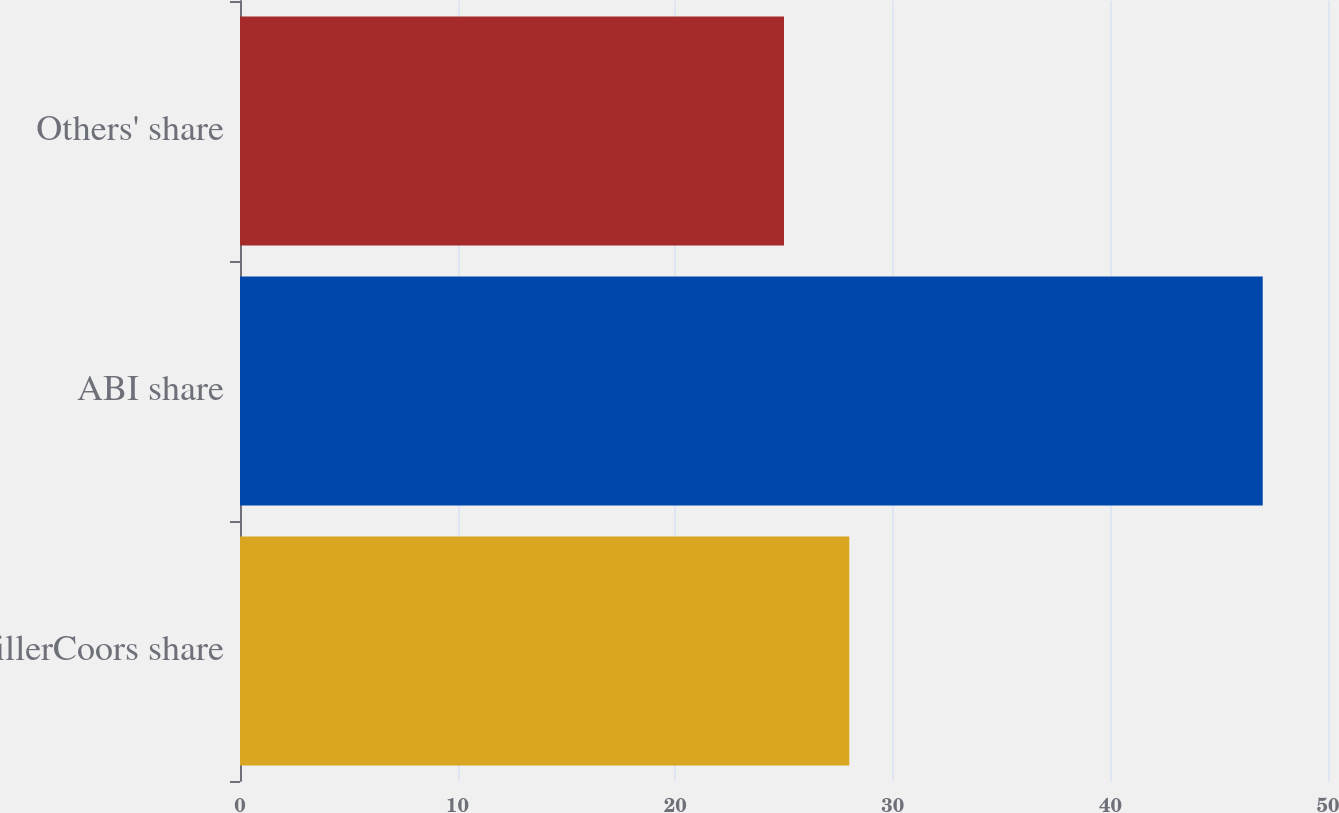Convert chart to OTSL. <chart><loc_0><loc_0><loc_500><loc_500><bar_chart><fcel>MillerCoors share<fcel>ABI share<fcel>Others' share<nl><fcel>28<fcel>47<fcel>25<nl></chart> 